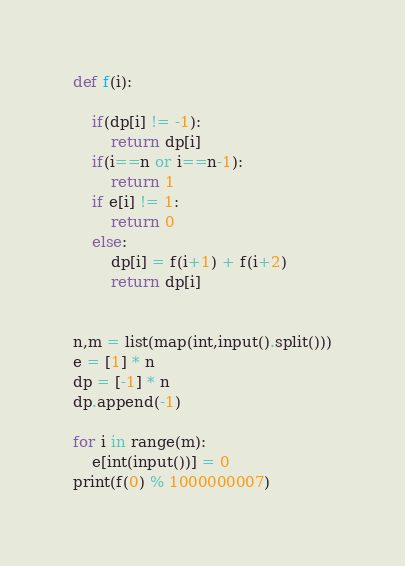Convert code to text. <code><loc_0><loc_0><loc_500><loc_500><_Python_>

def f(i):

    if(dp[i] != -1):
        return dp[i]
    if(i==n or i==n-1):
        return 1
    if e[i] != 1:
        return 0
    else:
        dp[i] = f(i+1) + f(i+2)
        return dp[i]


n,m = list(map(int,input().split()))
e = [1] * n
dp = [-1] * n
dp.append(-1)

for i in range(m):
    e[int(input())] = 0
print(f(0) % 1000000007)</code> 